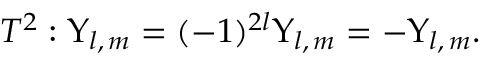Convert formula to latex. <formula><loc_0><loc_0><loc_500><loc_500>T ^ { 2 } \colon \Upsilon _ { l , \, m } = ( - 1 ) ^ { 2 l } \Upsilon _ { l , \, m } = - \Upsilon _ { l , \, m } .</formula> 